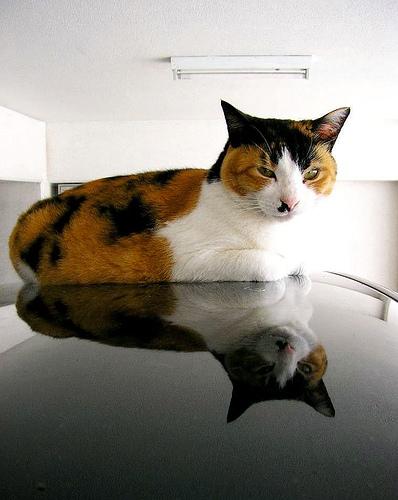What color is the spot below the cat's nose?
Give a very brief answer. Black. Can you see the cat's reflection?
Write a very short answer. Yes. What color are the walls?
Quick response, please. White. 